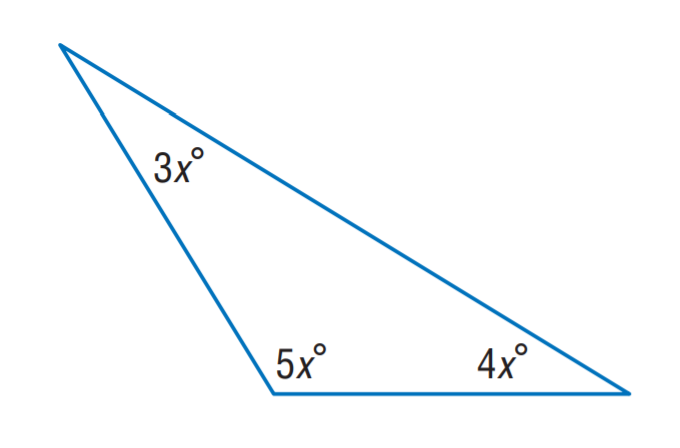Question: Find x.
Choices:
A. 5
B. 10
C. 15
D. 20
Answer with the letter. Answer: C 